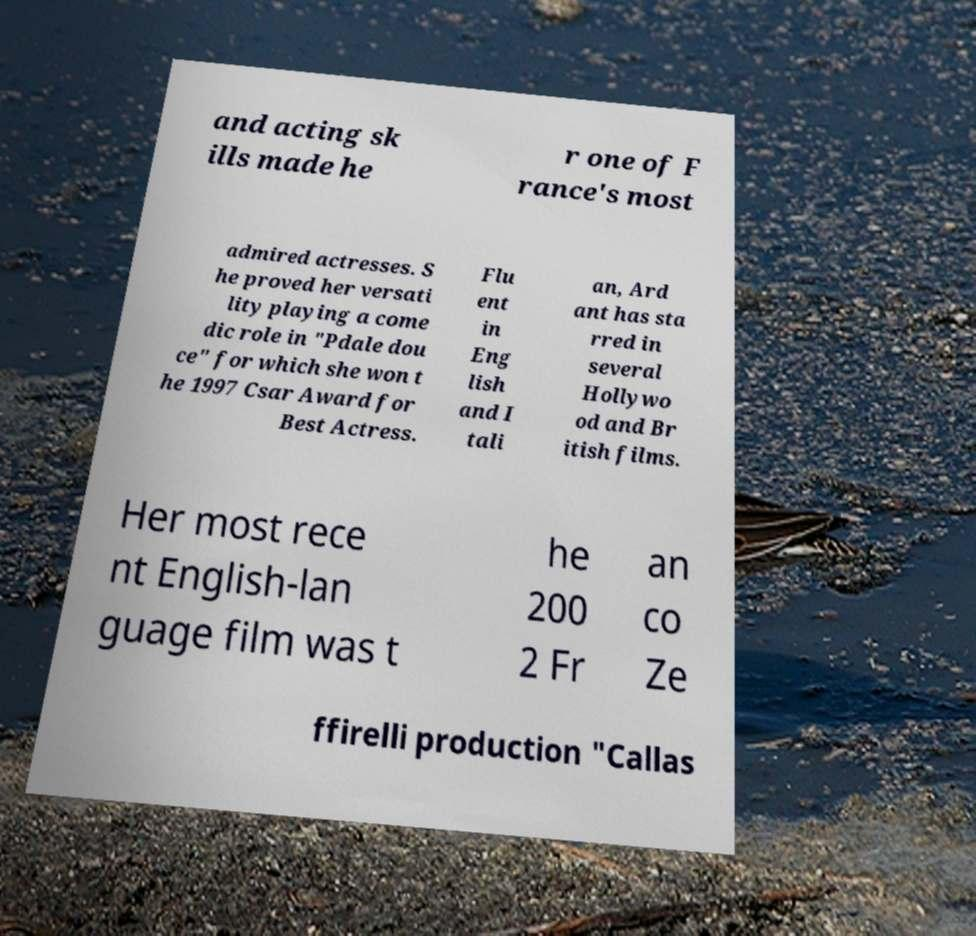For documentation purposes, I need the text within this image transcribed. Could you provide that? and acting sk ills made he r one of F rance's most admired actresses. S he proved her versati lity playing a come dic role in "Pdale dou ce" for which she won t he 1997 Csar Award for Best Actress. Flu ent in Eng lish and I tali an, Ard ant has sta rred in several Hollywo od and Br itish films. Her most rece nt English-lan guage film was t he 200 2 Fr an co Ze ffirelli production "Callas 